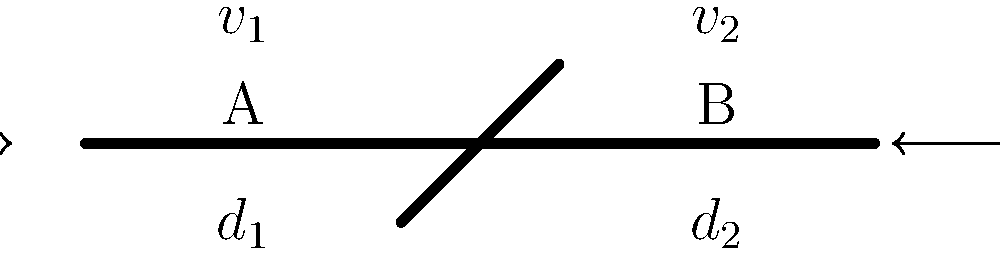In the simplified artery diagram shown, blood flows from left to right through a narrowed section. Given that the diameter at point A is $d_1 = 4$ mm and at point B is $d_2 = 3$ mm, and the velocity at point A is $v_1 = 30$ cm/s, calculate the velocity $v_2$ at point B. Assume blood is an incompressible fluid and the flow is steady. To solve this problem, we'll use the principle of continuity for incompressible fluids. The steps are as follows:

1) The continuity equation states that the volumetric flow rate is constant in a steady flow:

   $$Q_1 = Q_2$$

2) The volumetric flow rate is the product of velocity and cross-sectional area:

   $$A_1v_1 = A_2v_2$$

3) The cross-sectional area of a circular artery is $A = \pi r^2 = \pi (d/2)^2$:

   $$\pi (d_1/2)^2 v_1 = \pi (d_2/2)^2 v_2$$

4) Substitute the given values:

   $$\pi (4/2)^2 \cdot 30 = \pi (3/2)^2 v_2$$

5) The $\pi$ cancels out on both sides:

   $$(4/2)^2 \cdot 30 = (3/2)^2 v_2$$

6) Simplify:

   $$4 \cdot 30 = (9/4) v_2$$

7) Solve for $v_2$:

   $$v_2 = \frac{4 \cdot 30 \cdot 4}{9} = \frac{480}{9} = 53.33$$

Therefore, the velocity at point B is approximately 53.33 cm/s.
Answer: $v_2 \approx 53.33$ cm/s 